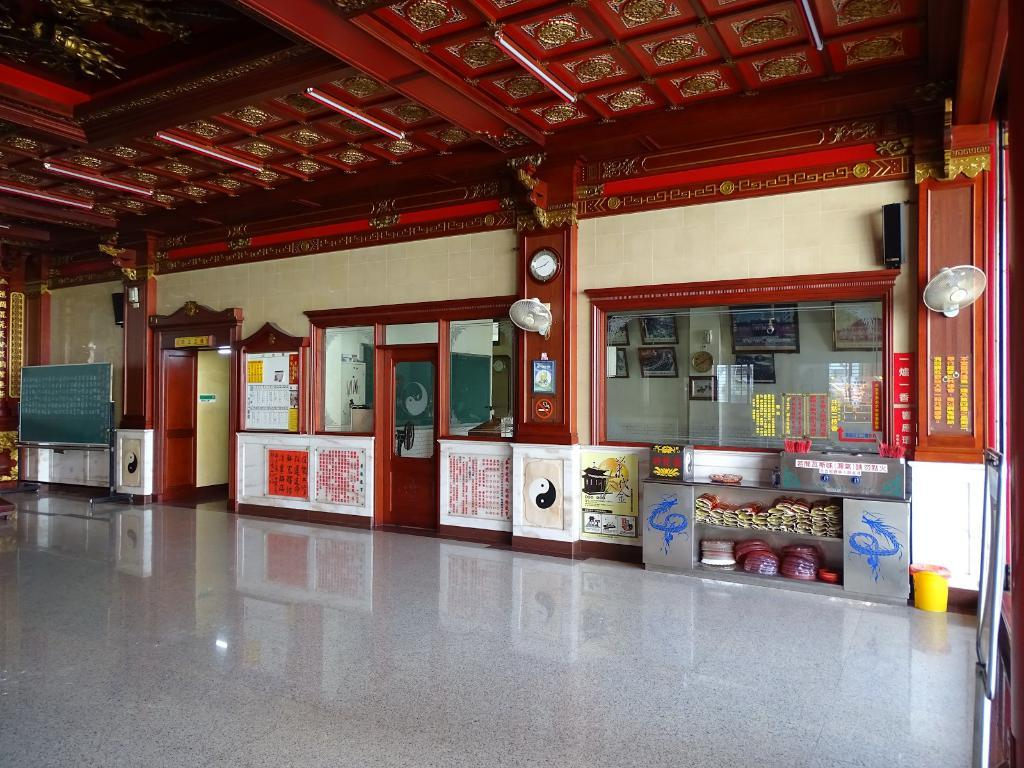<image>
Describe the image concisely. The exterior of a chinese restaurant shows a clock inside telling us it is 1:40. 